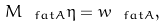Convert formula to latex. <formula><loc_0><loc_0><loc_500><loc_500>M _ { \ f a t A } \eta = w _ { \ f a t A } ,</formula> 